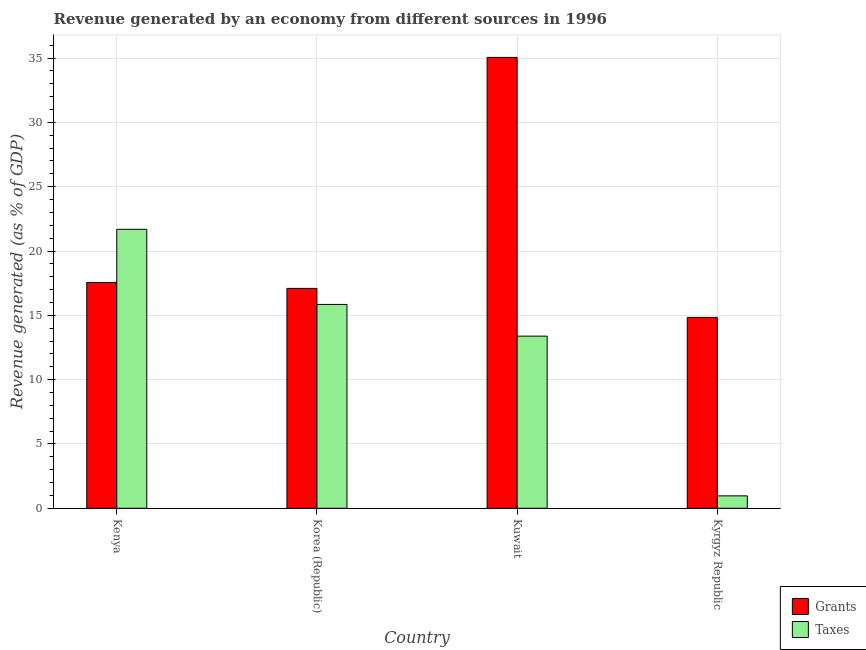How many different coloured bars are there?
Ensure brevity in your answer.  2. How many groups of bars are there?
Provide a short and direct response. 4. What is the label of the 4th group of bars from the left?
Offer a very short reply. Kyrgyz Republic. In how many cases, is the number of bars for a given country not equal to the number of legend labels?
Provide a succinct answer. 0. What is the revenue generated by grants in Kuwait?
Provide a short and direct response. 35.05. Across all countries, what is the maximum revenue generated by grants?
Your response must be concise. 35.05. Across all countries, what is the minimum revenue generated by grants?
Offer a terse response. 14.84. In which country was the revenue generated by grants maximum?
Provide a succinct answer. Kuwait. In which country was the revenue generated by grants minimum?
Your answer should be very brief. Kyrgyz Republic. What is the total revenue generated by taxes in the graph?
Ensure brevity in your answer.  51.88. What is the difference between the revenue generated by grants in Korea (Republic) and that in Kuwait?
Offer a very short reply. -17.96. What is the difference between the revenue generated by grants in Kenya and the revenue generated by taxes in Korea (Republic)?
Ensure brevity in your answer.  1.71. What is the average revenue generated by taxes per country?
Ensure brevity in your answer.  12.97. What is the difference between the revenue generated by grants and revenue generated by taxes in Kuwait?
Make the answer very short. 21.67. In how many countries, is the revenue generated by grants greater than 20 %?
Ensure brevity in your answer.  1. What is the ratio of the revenue generated by taxes in Kuwait to that in Kyrgyz Republic?
Provide a short and direct response. 13.87. Is the revenue generated by grants in Kenya less than that in Kyrgyz Republic?
Provide a succinct answer. No. What is the difference between the highest and the second highest revenue generated by grants?
Your answer should be very brief. 17.5. What is the difference between the highest and the lowest revenue generated by taxes?
Offer a very short reply. 20.72. What does the 1st bar from the left in Kuwait represents?
Give a very brief answer. Grants. What does the 2nd bar from the right in Korea (Republic) represents?
Provide a short and direct response. Grants. How many bars are there?
Give a very brief answer. 8. How many countries are there in the graph?
Give a very brief answer. 4. What is the difference between two consecutive major ticks on the Y-axis?
Your answer should be very brief. 5. Does the graph contain grids?
Your answer should be very brief. Yes. What is the title of the graph?
Keep it short and to the point. Revenue generated by an economy from different sources in 1996. Does "Long-term debt" appear as one of the legend labels in the graph?
Your response must be concise. No. What is the label or title of the X-axis?
Your answer should be very brief. Country. What is the label or title of the Y-axis?
Ensure brevity in your answer.  Revenue generated (as % of GDP). What is the Revenue generated (as % of GDP) in Grants in Kenya?
Provide a short and direct response. 17.55. What is the Revenue generated (as % of GDP) in Taxes in Kenya?
Your response must be concise. 21.69. What is the Revenue generated (as % of GDP) of Grants in Korea (Republic)?
Offer a very short reply. 17.09. What is the Revenue generated (as % of GDP) of Taxes in Korea (Republic)?
Ensure brevity in your answer.  15.85. What is the Revenue generated (as % of GDP) in Grants in Kuwait?
Your answer should be compact. 35.05. What is the Revenue generated (as % of GDP) of Taxes in Kuwait?
Make the answer very short. 13.38. What is the Revenue generated (as % of GDP) of Grants in Kyrgyz Republic?
Offer a terse response. 14.84. What is the Revenue generated (as % of GDP) of Taxes in Kyrgyz Republic?
Offer a very short reply. 0.97. Across all countries, what is the maximum Revenue generated (as % of GDP) in Grants?
Your response must be concise. 35.05. Across all countries, what is the maximum Revenue generated (as % of GDP) of Taxes?
Make the answer very short. 21.69. Across all countries, what is the minimum Revenue generated (as % of GDP) of Grants?
Your answer should be compact. 14.84. Across all countries, what is the minimum Revenue generated (as % of GDP) in Taxes?
Make the answer very short. 0.97. What is the total Revenue generated (as % of GDP) of Grants in the graph?
Ensure brevity in your answer.  84.53. What is the total Revenue generated (as % of GDP) in Taxes in the graph?
Ensure brevity in your answer.  51.88. What is the difference between the Revenue generated (as % of GDP) of Grants in Kenya and that in Korea (Republic)?
Offer a terse response. 0.46. What is the difference between the Revenue generated (as % of GDP) in Taxes in Kenya and that in Korea (Republic)?
Offer a very short reply. 5.84. What is the difference between the Revenue generated (as % of GDP) of Grants in Kenya and that in Kuwait?
Provide a short and direct response. -17.5. What is the difference between the Revenue generated (as % of GDP) of Taxes in Kenya and that in Kuwait?
Offer a terse response. 8.3. What is the difference between the Revenue generated (as % of GDP) of Grants in Kenya and that in Kyrgyz Republic?
Give a very brief answer. 2.72. What is the difference between the Revenue generated (as % of GDP) of Taxes in Kenya and that in Kyrgyz Republic?
Your answer should be very brief. 20.72. What is the difference between the Revenue generated (as % of GDP) of Grants in Korea (Republic) and that in Kuwait?
Make the answer very short. -17.96. What is the difference between the Revenue generated (as % of GDP) of Taxes in Korea (Republic) and that in Kuwait?
Your response must be concise. 2.46. What is the difference between the Revenue generated (as % of GDP) of Grants in Korea (Republic) and that in Kyrgyz Republic?
Your answer should be very brief. 2.26. What is the difference between the Revenue generated (as % of GDP) of Taxes in Korea (Republic) and that in Kyrgyz Republic?
Ensure brevity in your answer.  14.88. What is the difference between the Revenue generated (as % of GDP) of Grants in Kuwait and that in Kyrgyz Republic?
Your answer should be very brief. 20.21. What is the difference between the Revenue generated (as % of GDP) in Taxes in Kuwait and that in Kyrgyz Republic?
Offer a very short reply. 12.42. What is the difference between the Revenue generated (as % of GDP) in Grants in Kenya and the Revenue generated (as % of GDP) in Taxes in Korea (Republic)?
Your answer should be compact. 1.71. What is the difference between the Revenue generated (as % of GDP) of Grants in Kenya and the Revenue generated (as % of GDP) of Taxes in Kuwait?
Your response must be concise. 4.17. What is the difference between the Revenue generated (as % of GDP) of Grants in Kenya and the Revenue generated (as % of GDP) of Taxes in Kyrgyz Republic?
Your answer should be compact. 16.59. What is the difference between the Revenue generated (as % of GDP) of Grants in Korea (Republic) and the Revenue generated (as % of GDP) of Taxes in Kuwait?
Your response must be concise. 3.71. What is the difference between the Revenue generated (as % of GDP) in Grants in Korea (Republic) and the Revenue generated (as % of GDP) in Taxes in Kyrgyz Republic?
Your answer should be compact. 16.13. What is the difference between the Revenue generated (as % of GDP) in Grants in Kuwait and the Revenue generated (as % of GDP) in Taxes in Kyrgyz Republic?
Give a very brief answer. 34.09. What is the average Revenue generated (as % of GDP) of Grants per country?
Make the answer very short. 21.13. What is the average Revenue generated (as % of GDP) of Taxes per country?
Keep it short and to the point. 12.97. What is the difference between the Revenue generated (as % of GDP) in Grants and Revenue generated (as % of GDP) in Taxes in Kenya?
Your answer should be compact. -4.13. What is the difference between the Revenue generated (as % of GDP) in Grants and Revenue generated (as % of GDP) in Taxes in Korea (Republic)?
Ensure brevity in your answer.  1.25. What is the difference between the Revenue generated (as % of GDP) in Grants and Revenue generated (as % of GDP) in Taxes in Kuwait?
Offer a very short reply. 21.67. What is the difference between the Revenue generated (as % of GDP) of Grants and Revenue generated (as % of GDP) of Taxes in Kyrgyz Republic?
Offer a terse response. 13.87. What is the ratio of the Revenue generated (as % of GDP) of Grants in Kenya to that in Korea (Republic)?
Offer a terse response. 1.03. What is the ratio of the Revenue generated (as % of GDP) of Taxes in Kenya to that in Korea (Republic)?
Keep it short and to the point. 1.37. What is the ratio of the Revenue generated (as % of GDP) in Grants in Kenya to that in Kuwait?
Provide a succinct answer. 0.5. What is the ratio of the Revenue generated (as % of GDP) in Taxes in Kenya to that in Kuwait?
Ensure brevity in your answer.  1.62. What is the ratio of the Revenue generated (as % of GDP) of Grants in Kenya to that in Kyrgyz Republic?
Offer a very short reply. 1.18. What is the ratio of the Revenue generated (as % of GDP) in Taxes in Kenya to that in Kyrgyz Republic?
Offer a terse response. 22.47. What is the ratio of the Revenue generated (as % of GDP) of Grants in Korea (Republic) to that in Kuwait?
Offer a very short reply. 0.49. What is the ratio of the Revenue generated (as % of GDP) in Taxes in Korea (Republic) to that in Kuwait?
Provide a succinct answer. 1.18. What is the ratio of the Revenue generated (as % of GDP) of Grants in Korea (Republic) to that in Kyrgyz Republic?
Offer a terse response. 1.15. What is the ratio of the Revenue generated (as % of GDP) of Taxes in Korea (Republic) to that in Kyrgyz Republic?
Offer a very short reply. 16.42. What is the ratio of the Revenue generated (as % of GDP) of Grants in Kuwait to that in Kyrgyz Republic?
Offer a very short reply. 2.36. What is the ratio of the Revenue generated (as % of GDP) of Taxes in Kuwait to that in Kyrgyz Republic?
Give a very brief answer. 13.87. What is the difference between the highest and the second highest Revenue generated (as % of GDP) of Grants?
Give a very brief answer. 17.5. What is the difference between the highest and the second highest Revenue generated (as % of GDP) of Taxes?
Keep it short and to the point. 5.84. What is the difference between the highest and the lowest Revenue generated (as % of GDP) in Grants?
Keep it short and to the point. 20.21. What is the difference between the highest and the lowest Revenue generated (as % of GDP) of Taxes?
Give a very brief answer. 20.72. 